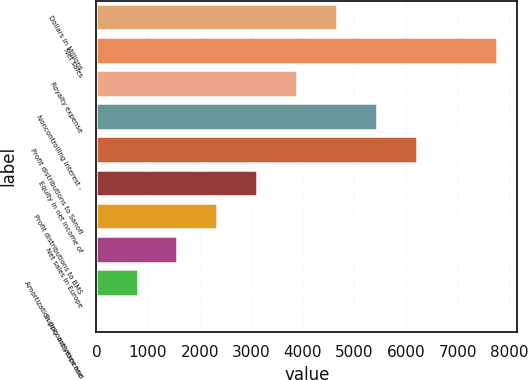Convert chart. <chart><loc_0><loc_0><loc_500><loc_500><bar_chart><fcel>Dollars in Millions<fcel>Net sales<fcel>Royalty expense<fcel>Noncontrolling interest -<fcel>Profit distributions to Sanofi<fcel>Equity in net income of<fcel>Profit distributions to BMS<fcel>Net sales in Europe<fcel>Amortization (income)/expense<fcel>Supply activities and<nl><fcel>4665.8<fcel>7761<fcel>3892<fcel>5439.6<fcel>6213.4<fcel>3118.2<fcel>2344.4<fcel>1570.6<fcel>796.8<fcel>23<nl></chart> 